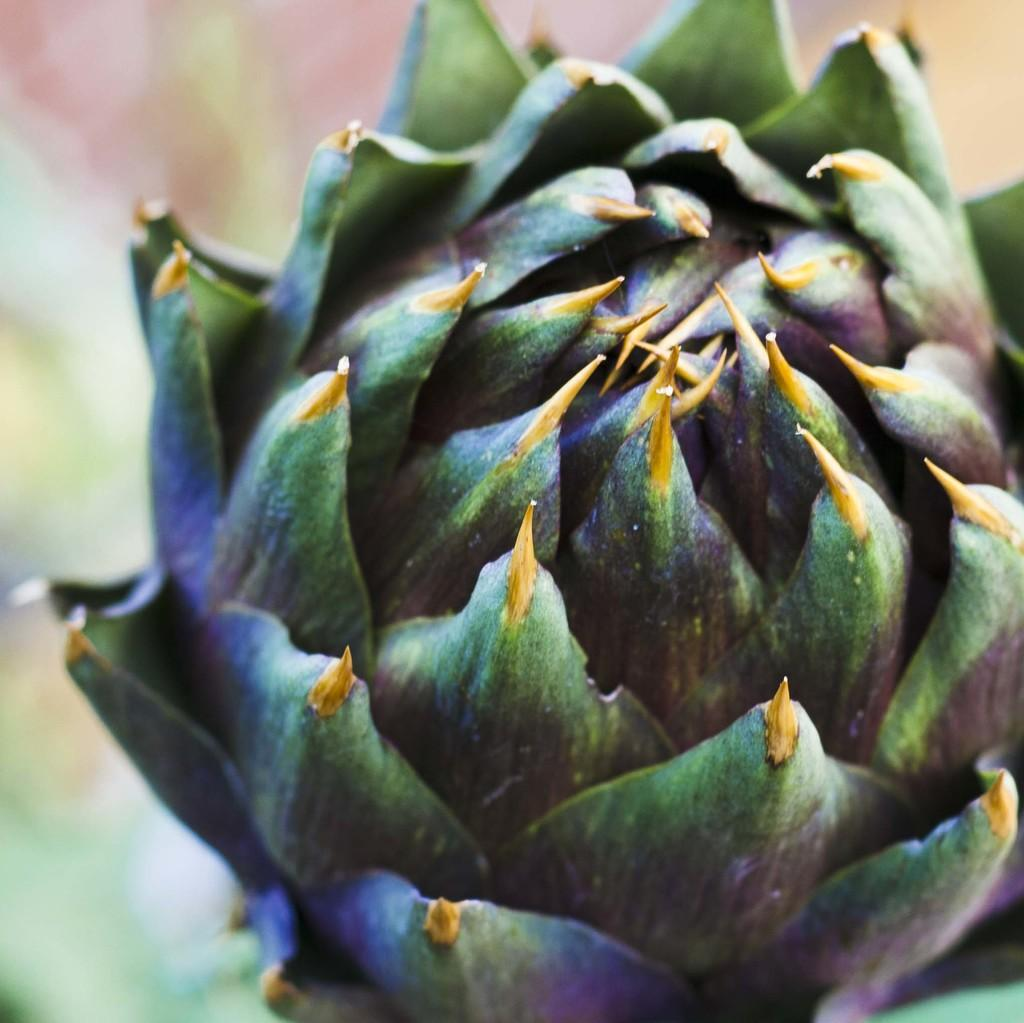What is the main subject in the foreground of the image? There is a flower in the foreground of the image. What can be observed about the background of the image? The background of the image is blurred. What type of trade is happening in the background of the image? There is no trade happening in the image, as the background is blurred and no specific activity can be observed. Can you see any fights taking place in the image? There are no fights depicted in the image; it features a flower in the foreground and a blurred background. 